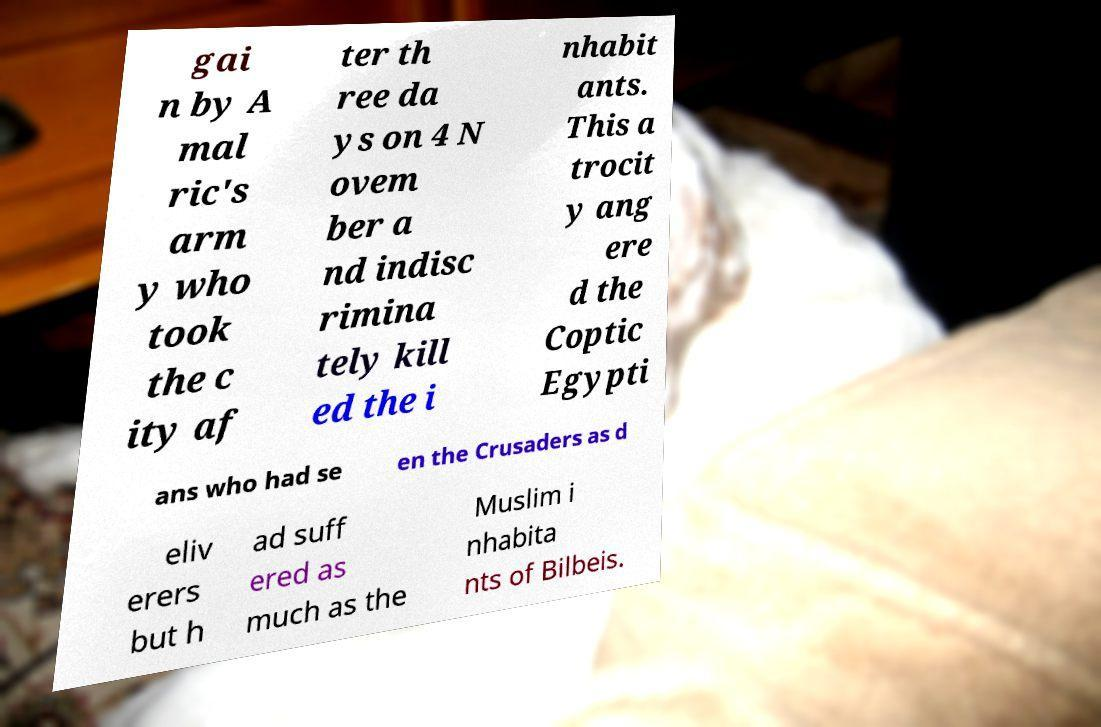Could you assist in decoding the text presented in this image and type it out clearly? gai n by A mal ric's arm y who took the c ity af ter th ree da ys on 4 N ovem ber a nd indisc rimina tely kill ed the i nhabit ants. This a trocit y ang ere d the Coptic Egypti ans who had se en the Crusaders as d eliv erers but h ad suff ered as much as the Muslim i nhabita nts of Bilbeis. 